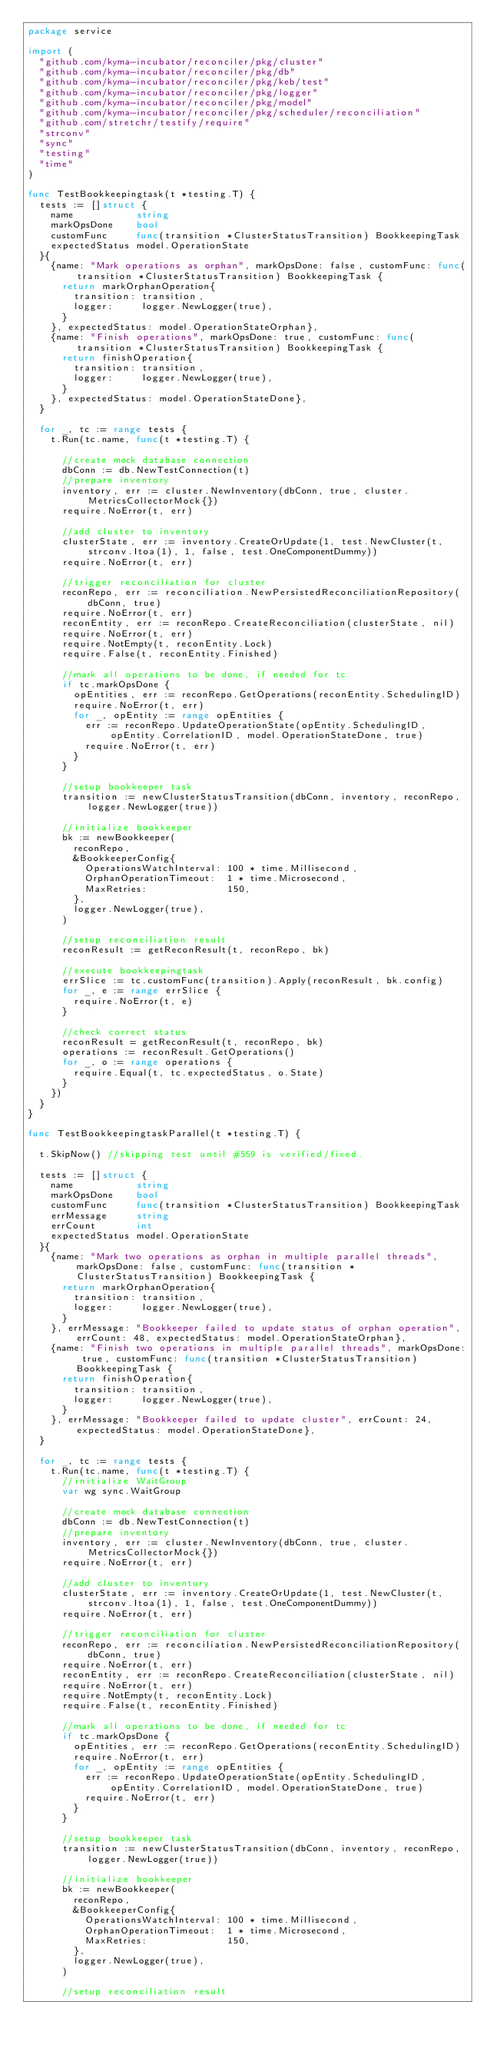<code> <loc_0><loc_0><loc_500><loc_500><_Go_>package service

import (
	"github.com/kyma-incubator/reconciler/pkg/cluster"
	"github.com/kyma-incubator/reconciler/pkg/db"
	"github.com/kyma-incubator/reconciler/pkg/keb/test"
	"github.com/kyma-incubator/reconciler/pkg/logger"
	"github.com/kyma-incubator/reconciler/pkg/model"
	"github.com/kyma-incubator/reconciler/pkg/scheduler/reconciliation"
	"github.com/stretchr/testify/require"
	"strconv"
	"sync"
	"testing"
	"time"
)

func TestBookkeepingtask(t *testing.T) {
	tests := []struct {
		name           string
		markOpsDone    bool
		customFunc     func(transition *ClusterStatusTransition) BookkeepingTask
		expectedStatus model.OperationState
	}{
		{name: "Mark operations as orphan", markOpsDone: false, customFunc: func(transition *ClusterStatusTransition) BookkeepingTask {
			return markOrphanOperation{
				transition: transition,
				logger:     logger.NewLogger(true),
			}
		}, expectedStatus: model.OperationStateOrphan},
		{name: "Finish operations", markOpsDone: true, customFunc: func(transition *ClusterStatusTransition) BookkeepingTask {
			return finishOperation{
				transition: transition,
				logger:     logger.NewLogger(true),
			}
		}, expectedStatus: model.OperationStateDone},
	}

	for _, tc := range tests {
		t.Run(tc.name, func(t *testing.T) {

			//create mock database connection
			dbConn := db.NewTestConnection(t)
			//prepare inventory
			inventory, err := cluster.NewInventory(dbConn, true, cluster.MetricsCollectorMock{})
			require.NoError(t, err)

			//add cluster to inventory
			clusterState, err := inventory.CreateOrUpdate(1, test.NewCluster(t, strconv.Itoa(1), 1, false, test.OneComponentDummy))
			require.NoError(t, err)

			//trigger reconciliation for cluster
			reconRepo, err := reconciliation.NewPersistedReconciliationRepository(dbConn, true)
			require.NoError(t, err)
			reconEntity, err := reconRepo.CreateReconciliation(clusterState, nil)
			require.NoError(t, err)
			require.NotEmpty(t, reconEntity.Lock)
			require.False(t, reconEntity.Finished)

			//mark all operations to be done, if needed for tc
			if tc.markOpsDone {
				opEntities, err := reconRepo.GetOperations(reconEntity.SchedulingID)
				require.NoError(t, err)
				for _, opEntity := range opEntities {
					err := reconRepo.UpdateOperationState(opEntity.SchedulingID, opEntity.CorrelationID, model.OperationStateDone, true)
					require.NoError(t, err)
				}
			}

			//setup bookkeeper task
			transition := newClusterStatusTransition(dbConn, inventory, reconRepo, logger.NewLogger(true))

			//initialize bookkeeper
			bk := newBookkeeper(
				reconRepo,
				&BookkeeperConfig{
					OperationsWatchInterval: 100 * time.Millisecond,
					OrphanOperationTimeout:  1 * time.Microsecond,
					MaxRetries:              150,
				},
				logger.NewLogger(true),
			)

			//setup reconciliation result
			reconResult := getReconResult(t, reconRepo, bk)

			//execute bookkeepingtask
			errSlice := tc.customFunc(transition).Apply(reconResult, bk.config)
			for _, e := range errSlice {
				require.NoError(t, e)
			}

			//check correct status
			reconResult = getReconResult(t, reconRepo, bk)
			operations := reconResult.GetOperations()
			for _, o := range operations {
				require.Equal(t, tc.expectedStatus, o.State)
			}
		})
	}
}

func TestBookkeepingtaskParallel(t *testing.T) {

	t.SkipNow() //skipping test until #559 is verified/fixed.

	tests := []struct {
		name           string
		markOpsDone    bool
		customFunc     func(transition *ClusterStatusTransition) BookkeepingTask
		errMessage     string
		errCount       int
		expectedStatus model.OperationState
	}{
		{name: "Mark two operations as orphan in multiple parallel threads", markOpsDone: false, customFunc: func(transition *ClusterStatusTransition) BookkeepingTask {
			return markOrphanOperation{
				transition: transition,
				logger:     logger.NewLogger(true),
			}
		}, errMessage: "Bookkeeper failed to update status of orphan operation", errCount: 48, expectedStatus: model.OperationStateOrphan},
		{name: "Finish two operations in multiple parallel threads", markOpsDone: true, customFunc: func(transition *ClusterStatusTransition) BookkeepingTask {
			return finishOperation{
				transition: transition,
				logger:     logger.NewLogger(true),
			}
		}, errMessage: "Bookkeeper failed to update cluster", errCount: 24, expectedStatus: model.OperationStateDone},
	}

	for _, tc := range tests {
		t.Run(tc.name, func(t *testing.T) {
			//initialize WaitGroup
			var wg sync.WaitGroup

			//create mock database connection
			dbConn := db.NewTestConnection(t)
			//prepare inventory
			inventory, err := cluster.NewInventory(dbConn, true, cluster.MetricsCollectorMock{})
			require.NoError(t, err)

			//add cluster to inventory
			clusterState, err := inventory.CreateOrUpdate(1, test.NewCluster(t, strconv.Itoa(1), 1, false, test.OneComponentDummy))
			require.NoError(t, err)

			//trigger reconciliation for cluster
			reconRepo, err := reconciliation.NewPersistedReconciliationRepository(dbConn, true)
			require.NoError(t, err)
			reconEntity, err := reconRepo.CreateReconciliation(clusterState, nil)
			require.NoError(t, err)
			require.NotEmpty(t, reconEntity.Lock)
			require.False(t, reconEntity.Finished)

			//mark all operations to be done, if needed for tc
			if tc.markOpsDone {
				opEntities, err := reconRepo.GetOperations(reconEntity.SchedulingID)
				require.NoError(t, err)
				for _, opEntity := range opEntities {
					err := reconRepo.UpdateOperationState(opEntity.SchedulingID, opEntity.CorrelationID, model.OperationStateDone, true)
					require.NoError(t, err)
				}
			}

			//setup bookkeeper task
			transition := newClusterStatusTransition(dbConn, inventory, reconRepo, logger.NewLogger(true))

			//initialize bookkeeper
			bk := newBookkeeper(
				reconRepo,
				&BookkeeperConfig{
					OperationsWatchInterval: 100 * time.Millisecond,
					OrphanOperationTimeout:  1 * time.Microsecond,
					MaxRetries:              150,
				},
				logger.NewLogger(true),
			)

			//setup reconciliation result</code> 